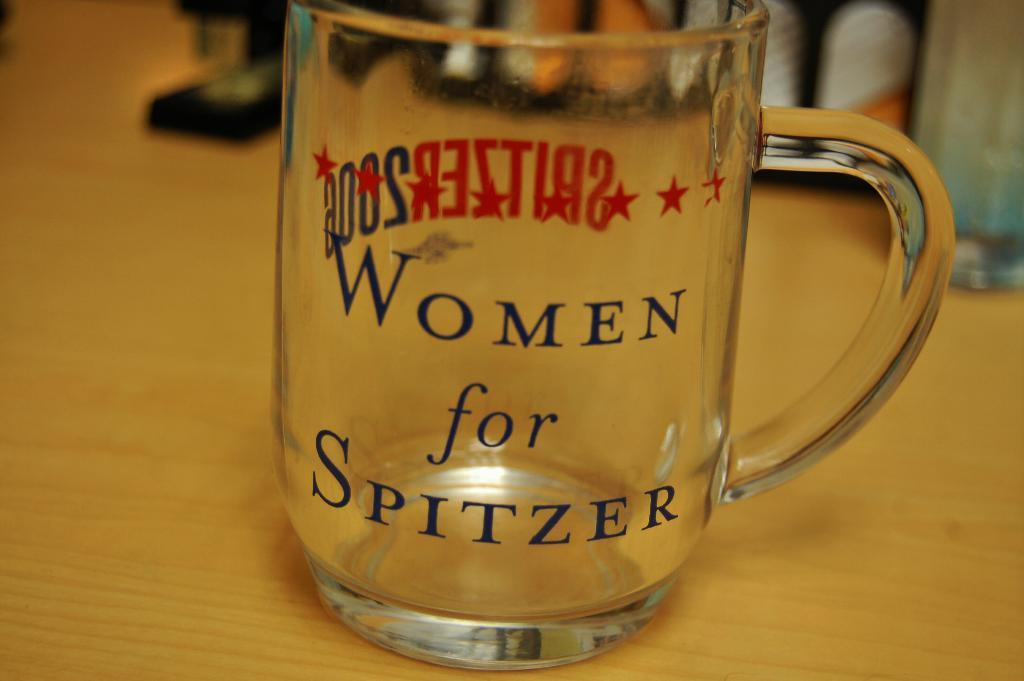What object is visible in the image? There is a cup in the image. Where is the cup located? The cup is placed on a table. What type of caption can be seen on the ground in the image? There is no caption present on the ground in the image; it only features a cup placed on a table. 